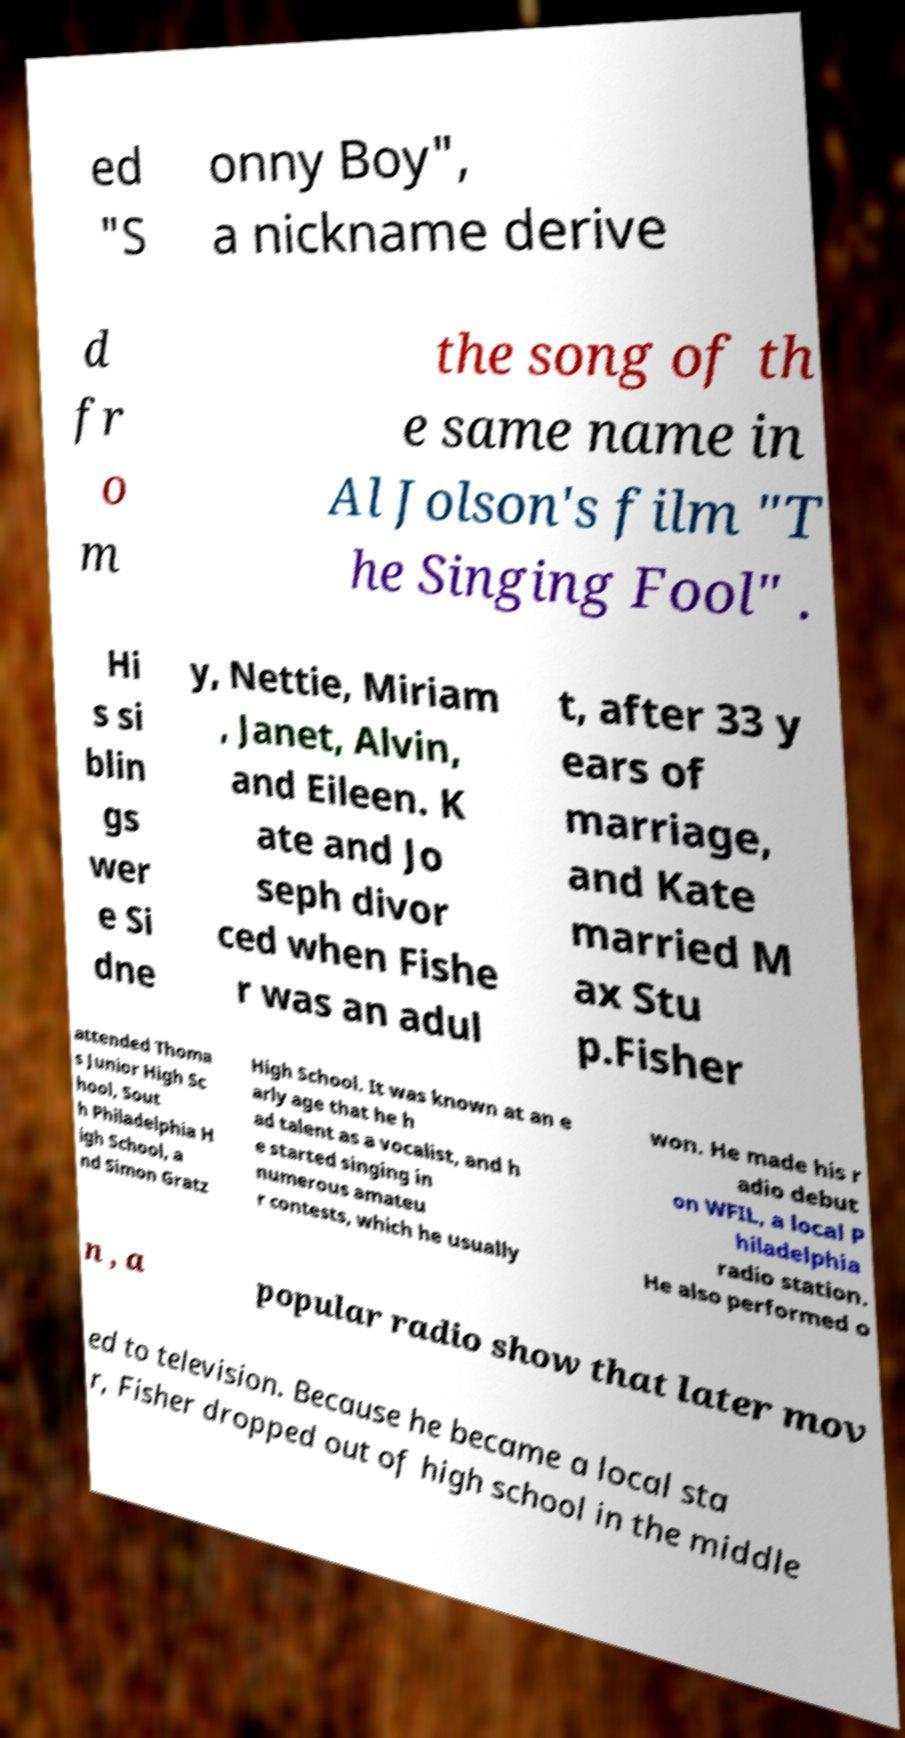Could you assist in decoding the text presented in this image and type it out clearly? ed "S onny Boy", a nickname derive d fr o m the song of th e same name in Al Jolson's film "T he Singing Fool" . Hi s si blin gs wer e Si dne y, Nettie, Miriam , Janet, Alvin, and Eileen. K ate and Jo seph divor ced when Fishe r was an adul t, after 33 y ears of marriage, and Kate married M ax Stu p.Fisher attended Thoma s Junior High Sc hool, Sout h Philadelphia H igh School, a nd Simon Gratz High School. It was known at an e arly age that he h ad talent as a vocalist, and h e started singing in numerous amateu r contests, which he usually won. He made his r adio debut on WFIL, a local P hiladelphia radio station. He also performed o n , a popular radio show that later mov ed to television. Because he became a local sta r, Fisher dropped out of high school in the middle 